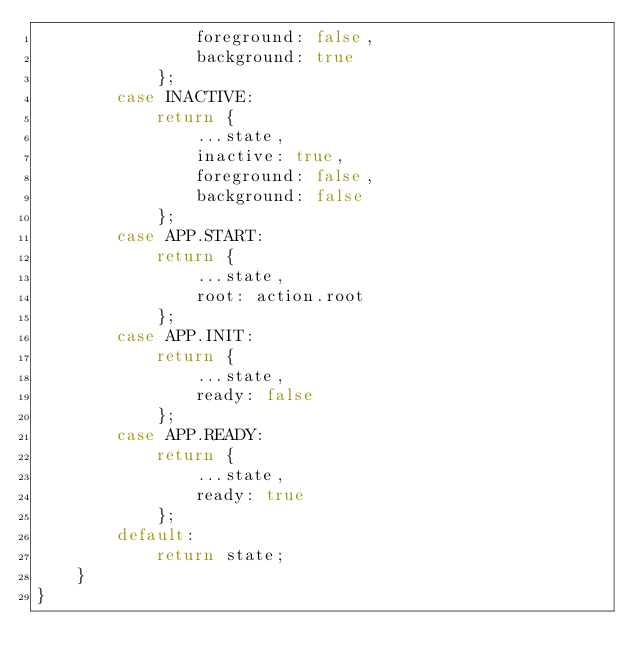<code> <loc_0><loc_0><loc_500><loc_500><_JavaScript_>				foreground: false,
				background: true
			};
		case INACTIVE:
			return {
				...state,
				inactive: true,
				foreground: false,
				background: false
			};
		case APP.START:
			return {
				...state,
				root: action.root
			};
		case APP.INIT:
			return {
				...state,
				ready: false
			};
		case APP.READY:
			return {
				...state,
				ready: true
			};
		default:
			return state;
	}
}
</code> 